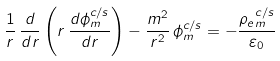Convert formula to latex. <formula><loc_0><loc_0><loc_500><loc_500>\frac { 1 } { r } \, \frac { d } { d r } \left ( r \, \frac { d \phi _ { m } ^ { c / s } } { d r } \right ) - \frac { m ^ { 2 } } { r ^ { 2 } } \, \phi _ { m } ^ { c / s } = - \frac { { \rho _ { e } } _ { m } ^ { c / s } } { \varepsilon _ { 0 } }</formula> 